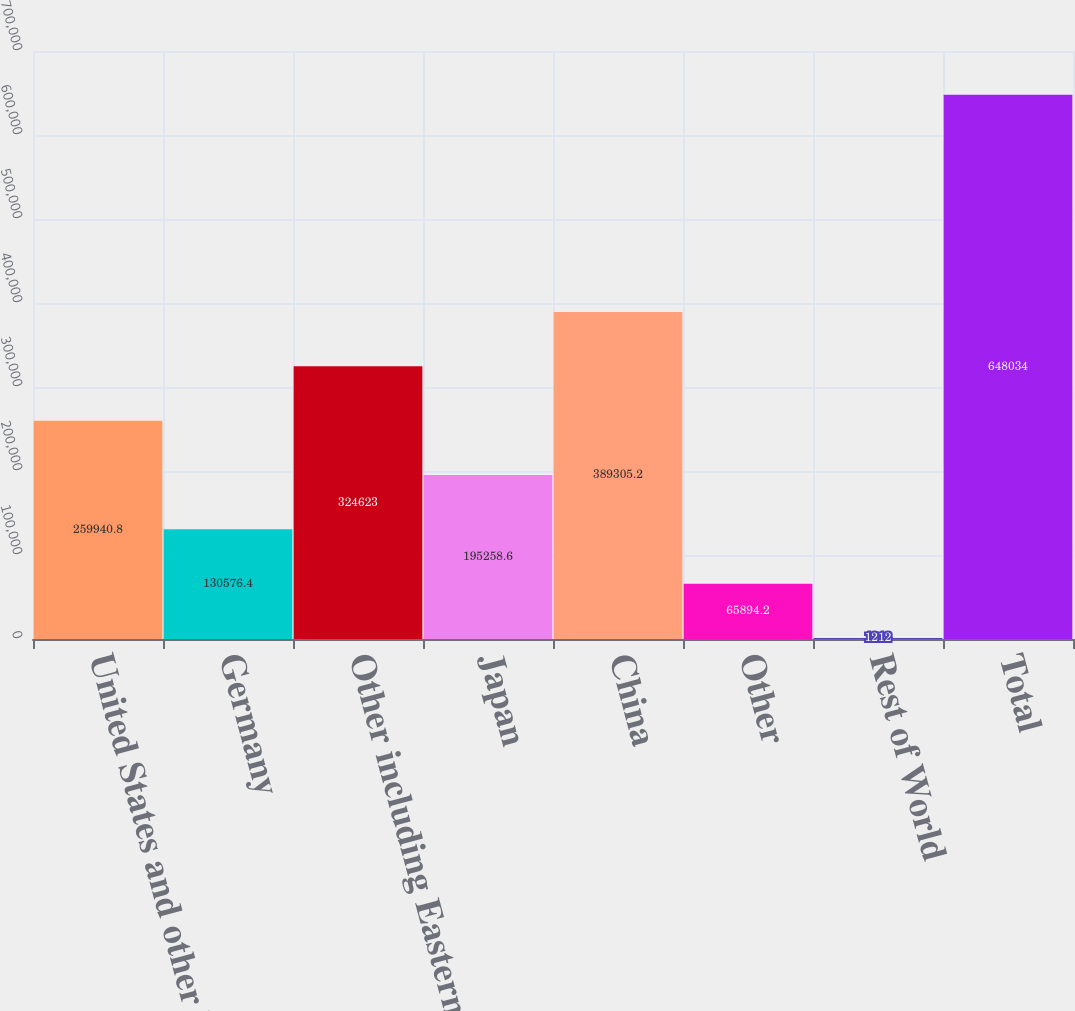Convert chart. <chart><loc_0><loc_0><loc_500><loc_500><bar_chart><fcel>United States and other North<fcel>Germany<fcel>Other including Eastern<fcel>Japan<fcel>China<fcel>Other<fcel>Rest of World<fcel>Total<nl><fcel>259941<fcel>130576<fcel>324623<fcel>195259<fcel>389305<fcel>65894.2<fcel>1212<fcel>648034<nl></chart> 